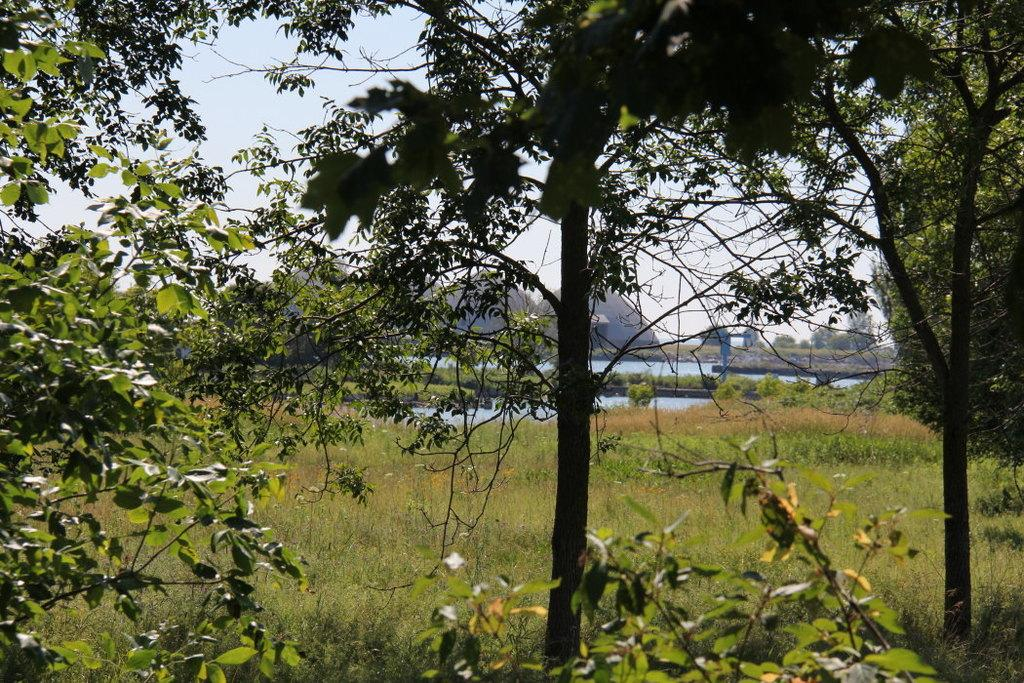What type of vegetation can be seen in the image? There are trees in the image. What is on the ground in the image? There is grass on the ground in the image. What can be seen besides the trees and grass? There is water visible in the image. What is visible above the trees and grass? The sky is visible in the image. What type of animal is writing a letter in the image? There is no animal present in the image, and no one is writing a letter. 